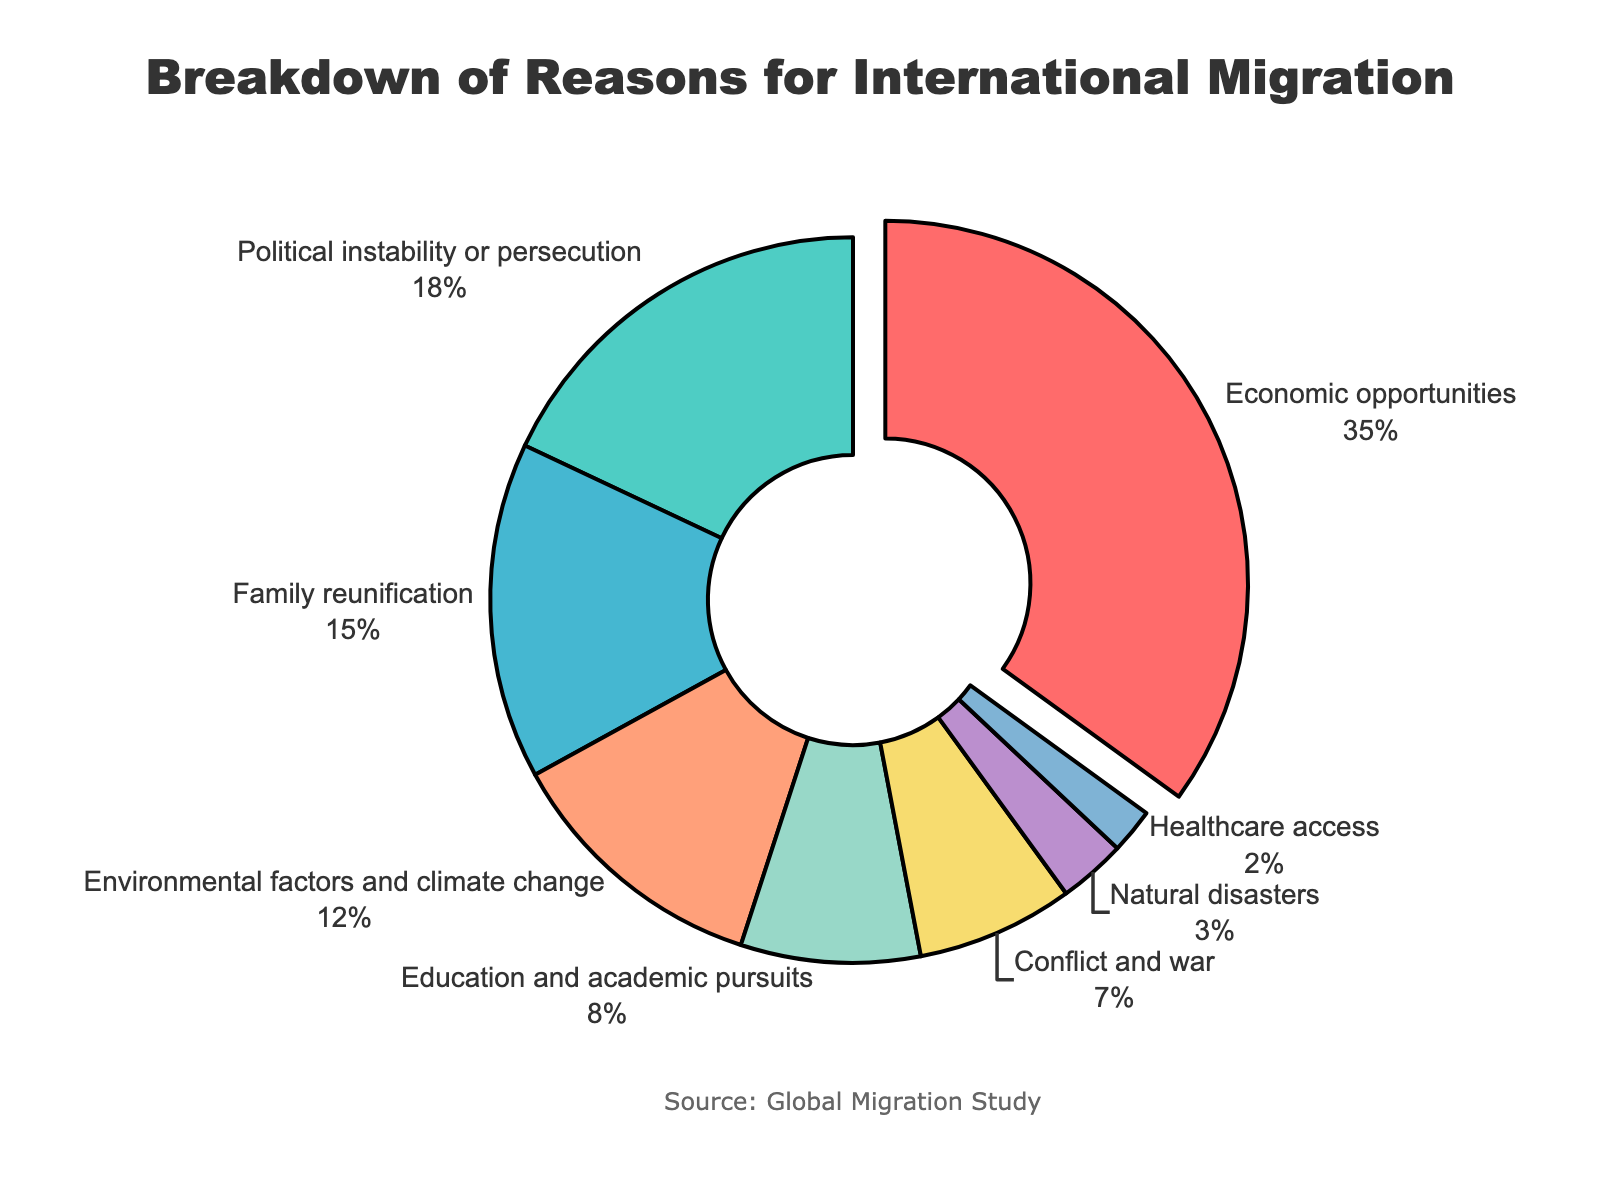Which reason for international migration has the highest percentage? The segment pulled away from the pie chart indicates the highest percentage. The label shows "Economic opportunities" with 35%.
Answer: Economic opportunities What is the combined percentage of migration due to political instability or persecution and conflict and war? Sum the percentages for "Political instability or persecution" (18%) and "Conflict and war" (7%): 18 + 7 = 25%.
Answer: 25% Which reason has the least impact on international migration according to the figure? The smallest segment in the pie chart represents the least impactful reason. The label shows "Healthcare access" with 2%.
Answer: Healthcare access Are there more people migrating due to economic opportunities than due to political instability or persecution? Compare the percentages for "Economic opportunities" (35%) and "Political instability or persecution" (18%). 35% is greater than 18%.
Answer: Yes How does the percentage of migration due to education and academic pursuits compare to that of environmental factors and climate change? Compare the percentages for "Education and academic pursuits" (8%) and "Environmental factors and climate change" (12%). 8% is less than 12%.
Answer: Education and academic pursuits is lower What is the total percentage of migration due to social reasons such as family reunification and healthcare access? Sum the percentages for "Family reunification" (15%) and "Healthcare access" (2%): 15 + 2 = 17%.
Answer: 17% Which category uses the green color in the pie chart? Observe the green section. The label in the green segment indicates "Political instability or persecution".
Answer: Political instability or persecution Is the percentage of migration due to natural disasters greater than that of healthcare access? Compare the percentages for "Natural disasters" (3%) and "Healthcare access" (2%). 3% is greater than 2%.
Answer: Yes What is the difference between the percentage of migration due to economic opportunities and environmental factors and climate change? Subtract the percentage of "Environmental factors and climate change" (12%) from "Economic opportunities" (35%): 35 - 12 = 23%.
Answer: 23% How many factors have above 10% influence on international migration? Identify the segments with percentages above 10%: "Economic opportunities" (35%), "Political instability or persecution" (18%), "Family reunification" (15%), "Environmental factors and climate change" (12%). There are 4 such factors.
Answer: 4 